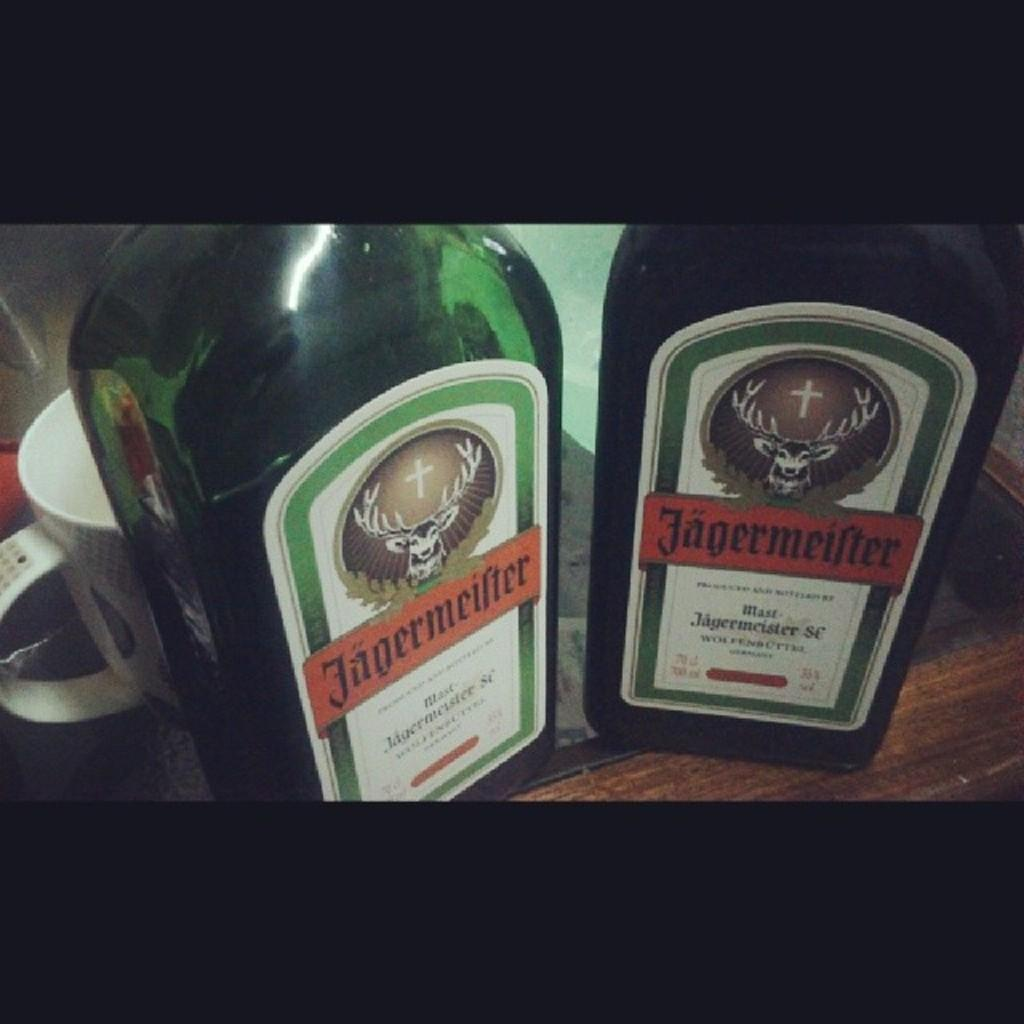<image>
Provide a brief description of the given image. Two bottles of Jagermeifer with a picture of a deer with a cross between the horns of the deer. 